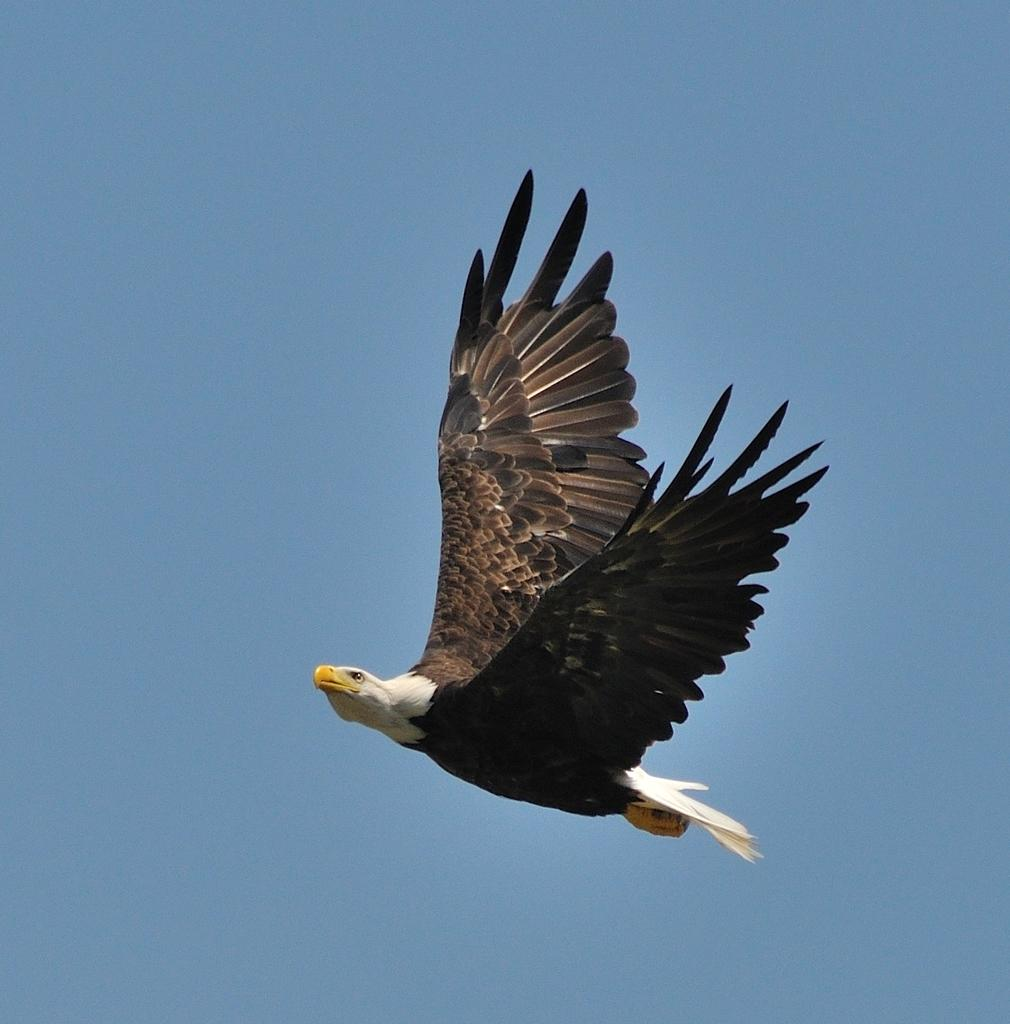What animal is the main subject of the picture? There is an eagle in the picture. What is the eagle doing in the image? The eagle is flying in the sky. What color is the eagle's beak? The eagle has a yellow color beak. What can be seen in the background of the image? The sky is visible in the background of the image. What is the color of the sky in the image? The sky is blue in color. What type of calculator is the eagle holding in its talons in the image? There is no calculator present in the image; the eagle is flying with its wings and beak visible. What kind of show is the eagle performing in the image? There is no show or performance depicted in the image; the eagle is simply flying in the sky. 